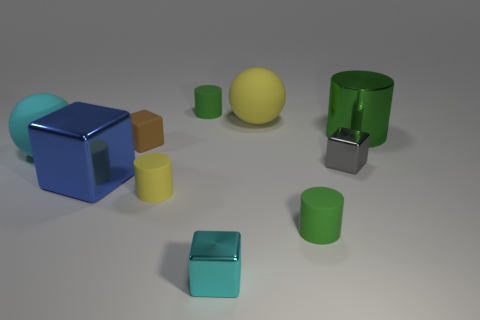Subtract all yellow rubber cylinders. How many cylinders are left? 3 Subtract all yellow cylinders. How many cylinders are left? 3 Subtract 1 cylinders. How many cylinders are left? 3 Subtract 1 gray cubes. How many objects are left? 9 Subtract all balls. How many objects are left? 8 Subtract all green cylinders. Subtract all purple blocks. How many cylinders are left? 1 Subtract all purple cubes. How many cyan spheres are left? 1 Subtract all large metallic blocks. Subtract all small green matte cylinders. How many objects are left? 7 Add 1 small yellow rubber objects. How many small yellow rubber objects are left? 2 Add 7 green metallic things. How many green metallic things exist? 8 